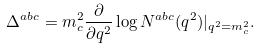<formula> <loc_0><loc_0><loc_500><loc_500>\Delta ^ { a b c } = m _ { c } ^ { 2 } \frac { \partial } { \partial q ^ { 2 } } \log N ^ { a b c } ( q ^ { 2 } ) | _ { q ^ { 2 } = m _ { c } ^ { 2 } } .</formula> 